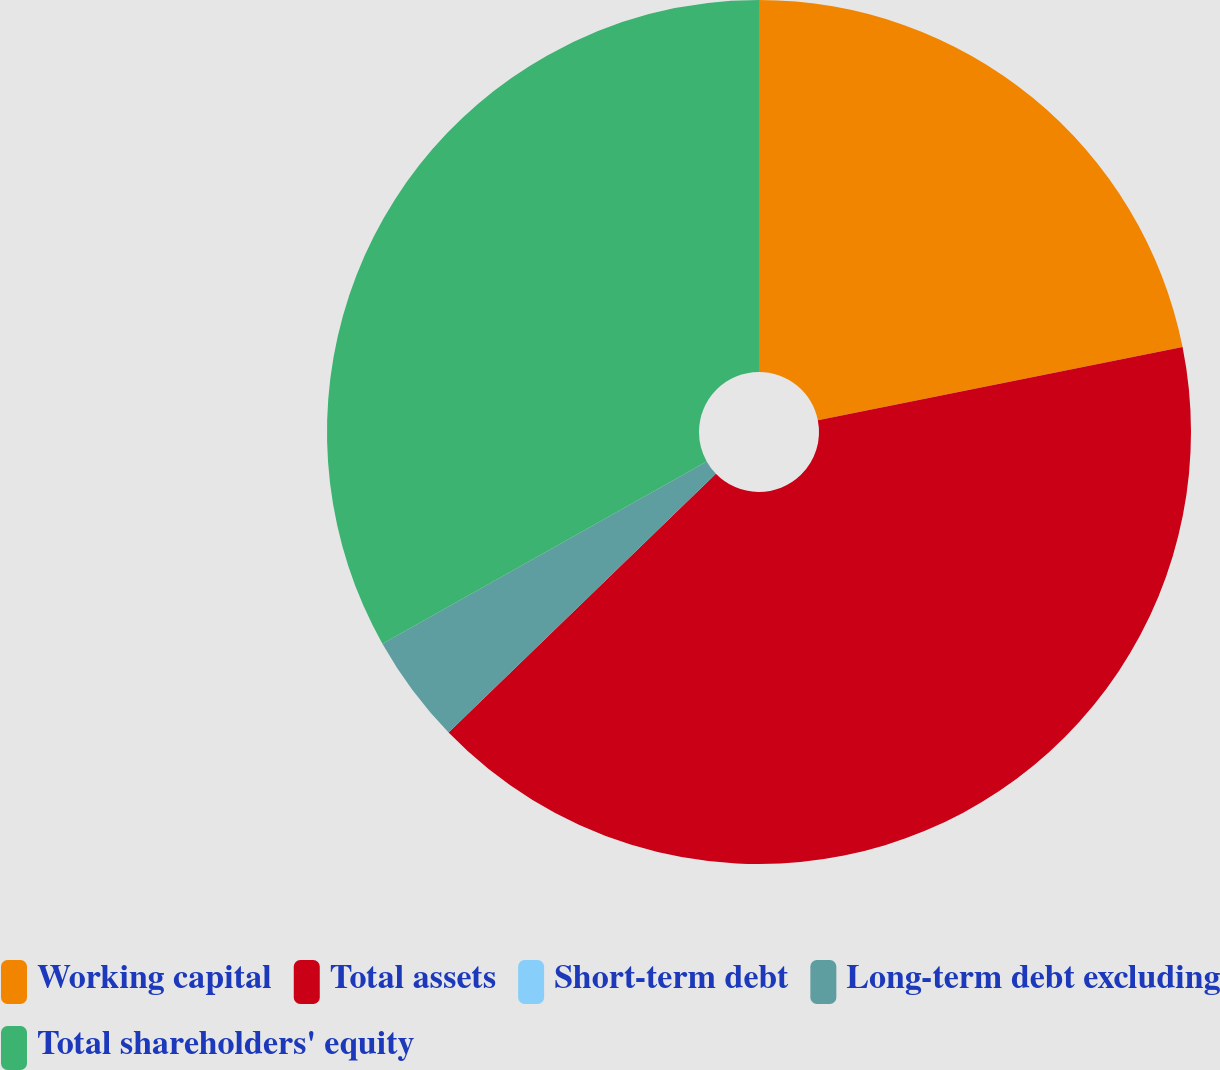Convert chart to OTSL. <chart><loc_0><loc_0><loc_500><loc_500><pie_chart><fcel>Working capital<fcel>Total assets<fcel>Short-term debt<fcel>Long-term debt excluding<fcel>Total shareholders' equity<nl><fcel>21.85%<fcel>40.91%<fcel>0.0%<fcel>4.09%<fcel>33.15%<nl></chart> 